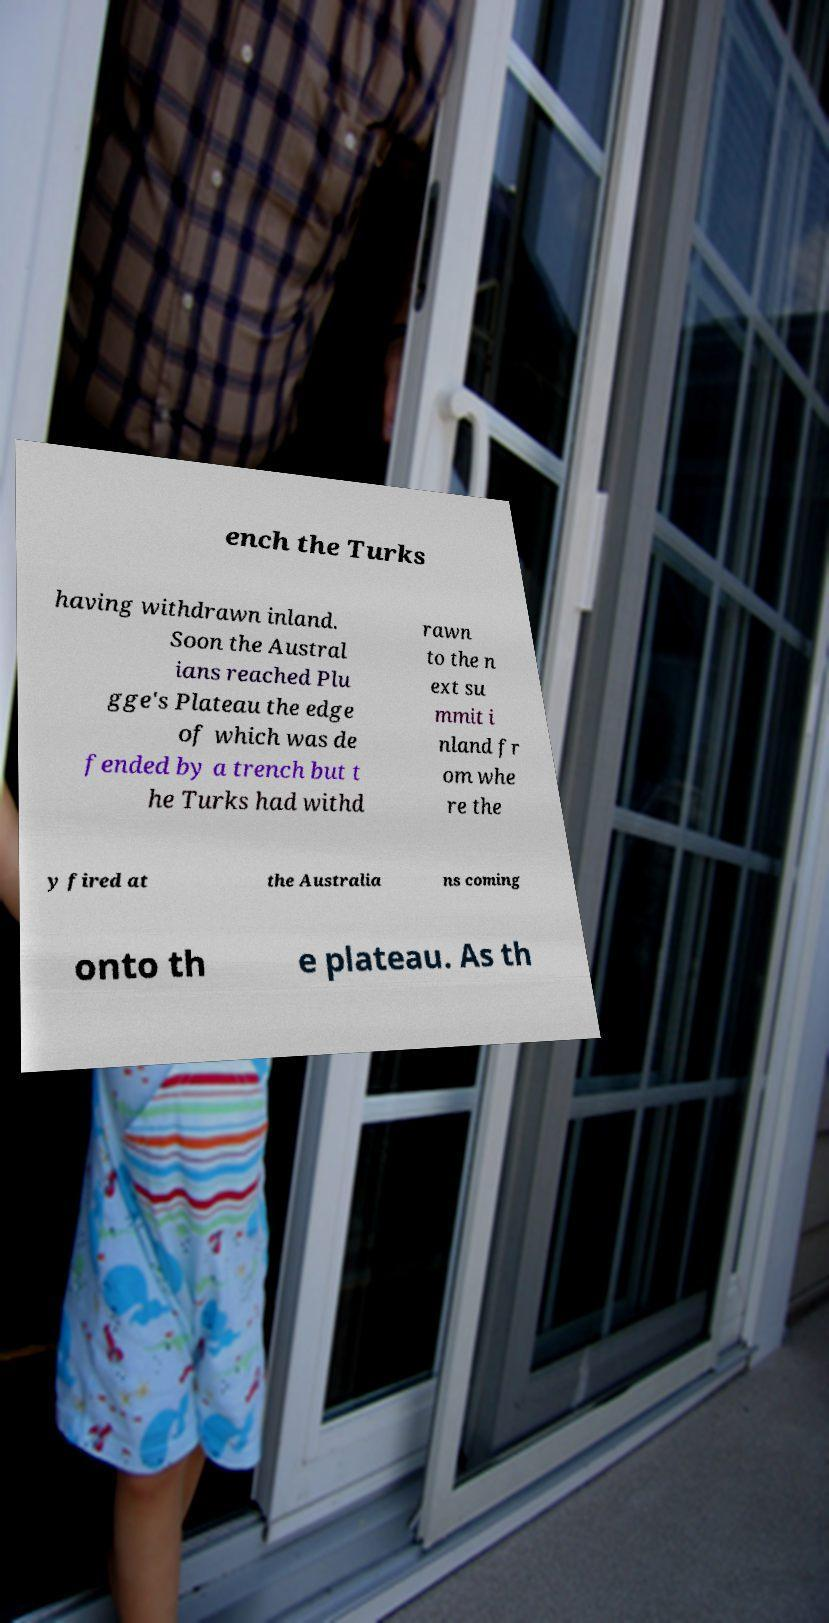What messages or text are displayed in this image? I need them in a readable, typed format. ench the Turks having withdrawn inland. Soon the Austral ians reached Plu gge's Plateau the edge of which was de fended by a trench but t he Turks had withd rawn to the n ext su mmit i nland fr om whe re the y fired at the Australia ns coming onto th e plateau. As th 